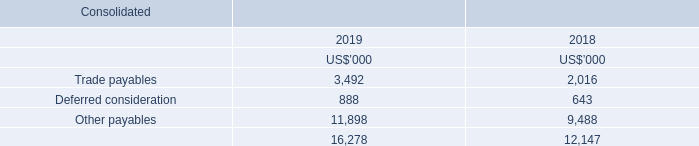Note 12. Current liabilities - trade and other payables
Accounting policy for trade and other payables 

These amounts represent liabilities for goods and services provided to the Group prior to the end of the financial year and which are unpaid. Due to their short-term nature they are measured at amortised cost and are not discounted. The amounts are unsecured and are usually paid within 30 days of recognition.
Deferred consideration 

The payable represents the obligation to pay consideration following the acquisition of a business or assets and is deferred based on passage of time. It is measured at the present value of the estimated liability.
What are the components of the liabilities? Trade payables, deferred consideration, other payables. What are the years included in the table? 2019, 2018. How is the payable measured? It is measured at the present value of the estimated liability. What is the percentage increase in the total trade and other payables from 2018 to 2019?
Answer scale should be: percent. (16,278-12,147)/12,147
Answer: 34.01. What is the percentage of trade payables as a ratio of current liabilities  in 2019?
Answer scale should be: percent. 3,492/16,278
Answer: 21.45. What is the percentage increase in other payables from 2018 to 2019?
Answer scale should be: percent. (11,898-9,488)/9,488
Answer: 25.4. 